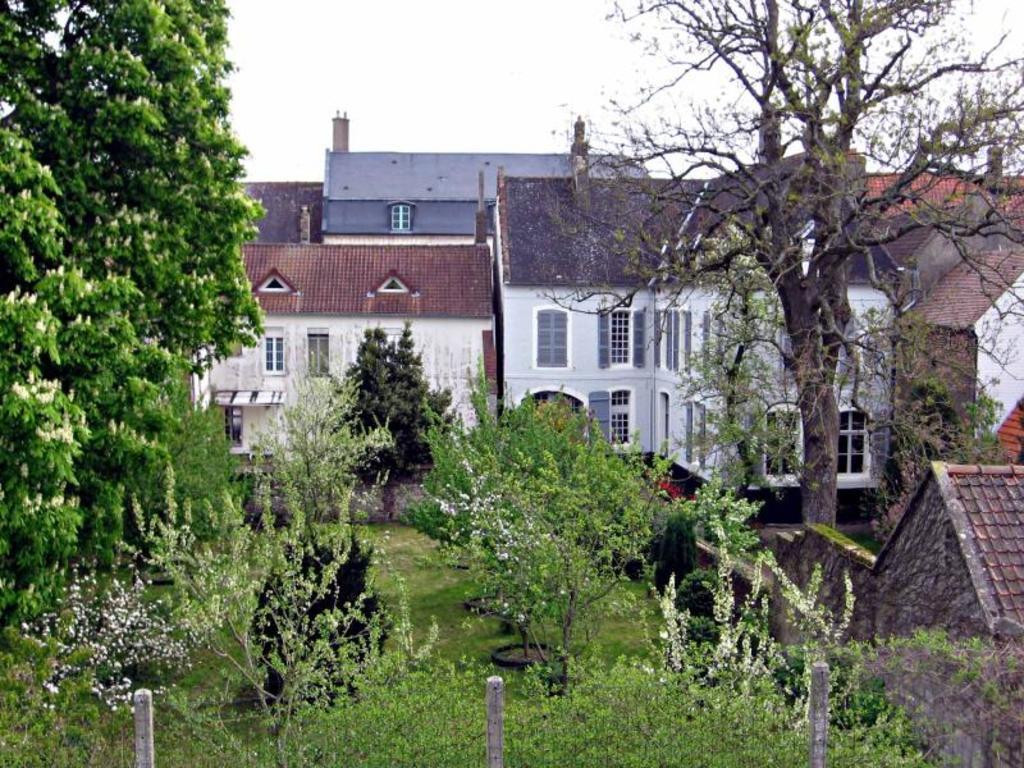Describe this image in one or two sentences. These are the houses with the windows. I can see the trees with the branches and leaves. This looks like a fence. I can see the plants. 